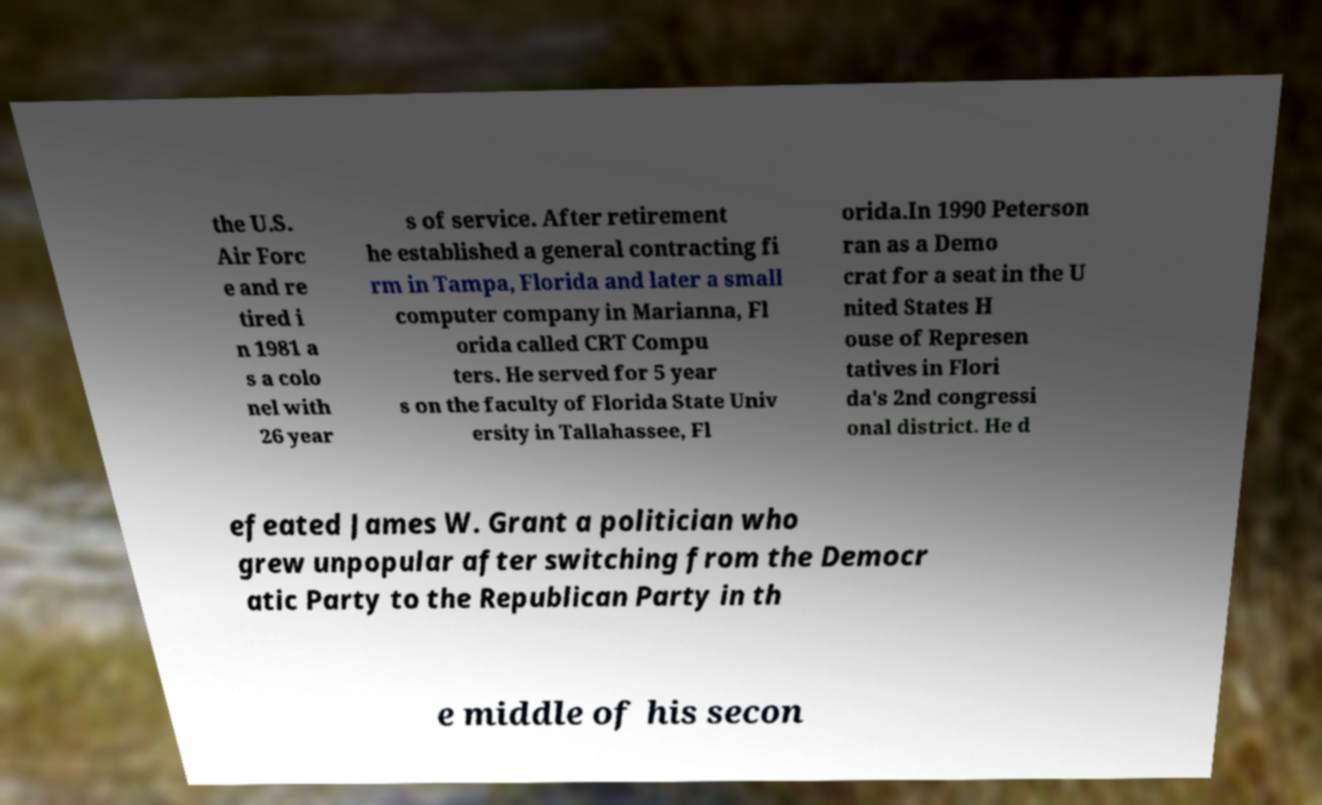There's text embedded in this image that I need extracted. Can you transcribe it verbatim? the U.S. Air Forc e and re tired i n 1981 a s a colo nel with 26 year s of service. After retirement he established a general contracting fi rm in Tampa, Florida and later a small computer company in Marianna, Fl orida called CRT Compu ters. He served for 5 year s on the faculty of Florida State Univ ersity in Tallahassee, Fl orida.In 1990 Peterson ran as a Demo crat for a seat in the U nited States H ouse of Represen tatives in Flori da's 2nd congressi onal district. He d efeated James W. Grant a politician who grew unpopular after switching from the Democr atic Party to the Republican Party in th e middle of his secon 